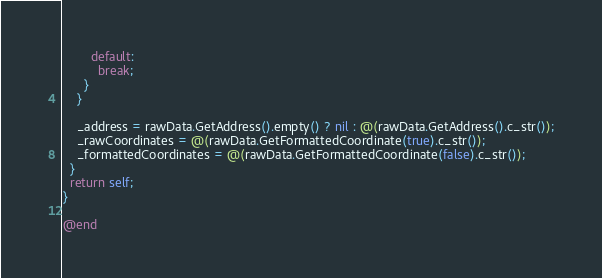<code> <loc_0><loc_0><loc_500><loc_500><_ObjectiveC_>        default:
          break;
      }
    }

    _address = rawData.GetAddress().empty() ? nil : @(rawData.GetAddress().c_str());
    _rawCoordinates = @(rawData.GetFormattedCoordinate(true).c_str());
    _formattedCoordinates = @(rawData.GetFormattedCoordinate(false).c_str());
  }
  return self;
}

@end
</code> 